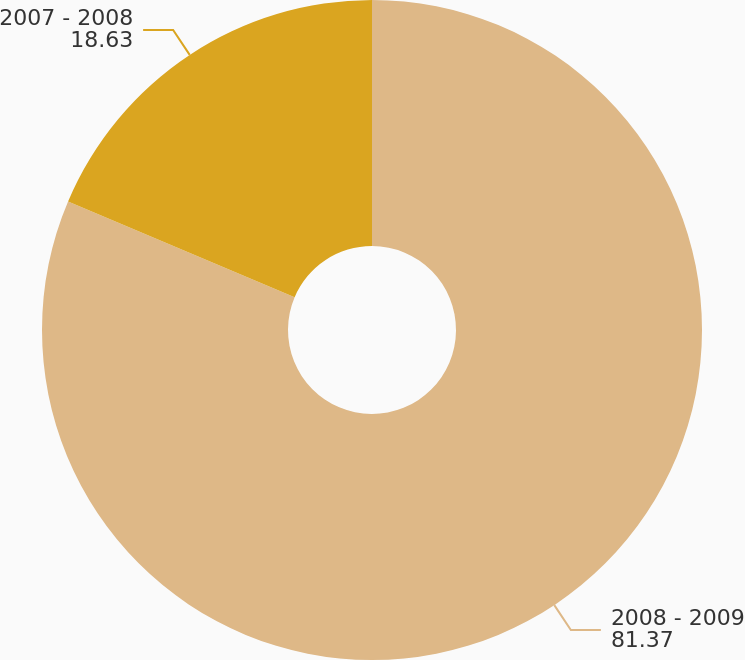Convert chart to OTSL. <chart><loc_0><loc_0><loc_500><loc_500><pie_chart><fcel>2008 - 2009<fcel>2007 - 2008<nl><fcel>81.37%<fcel>18.63%<nl></chart> 